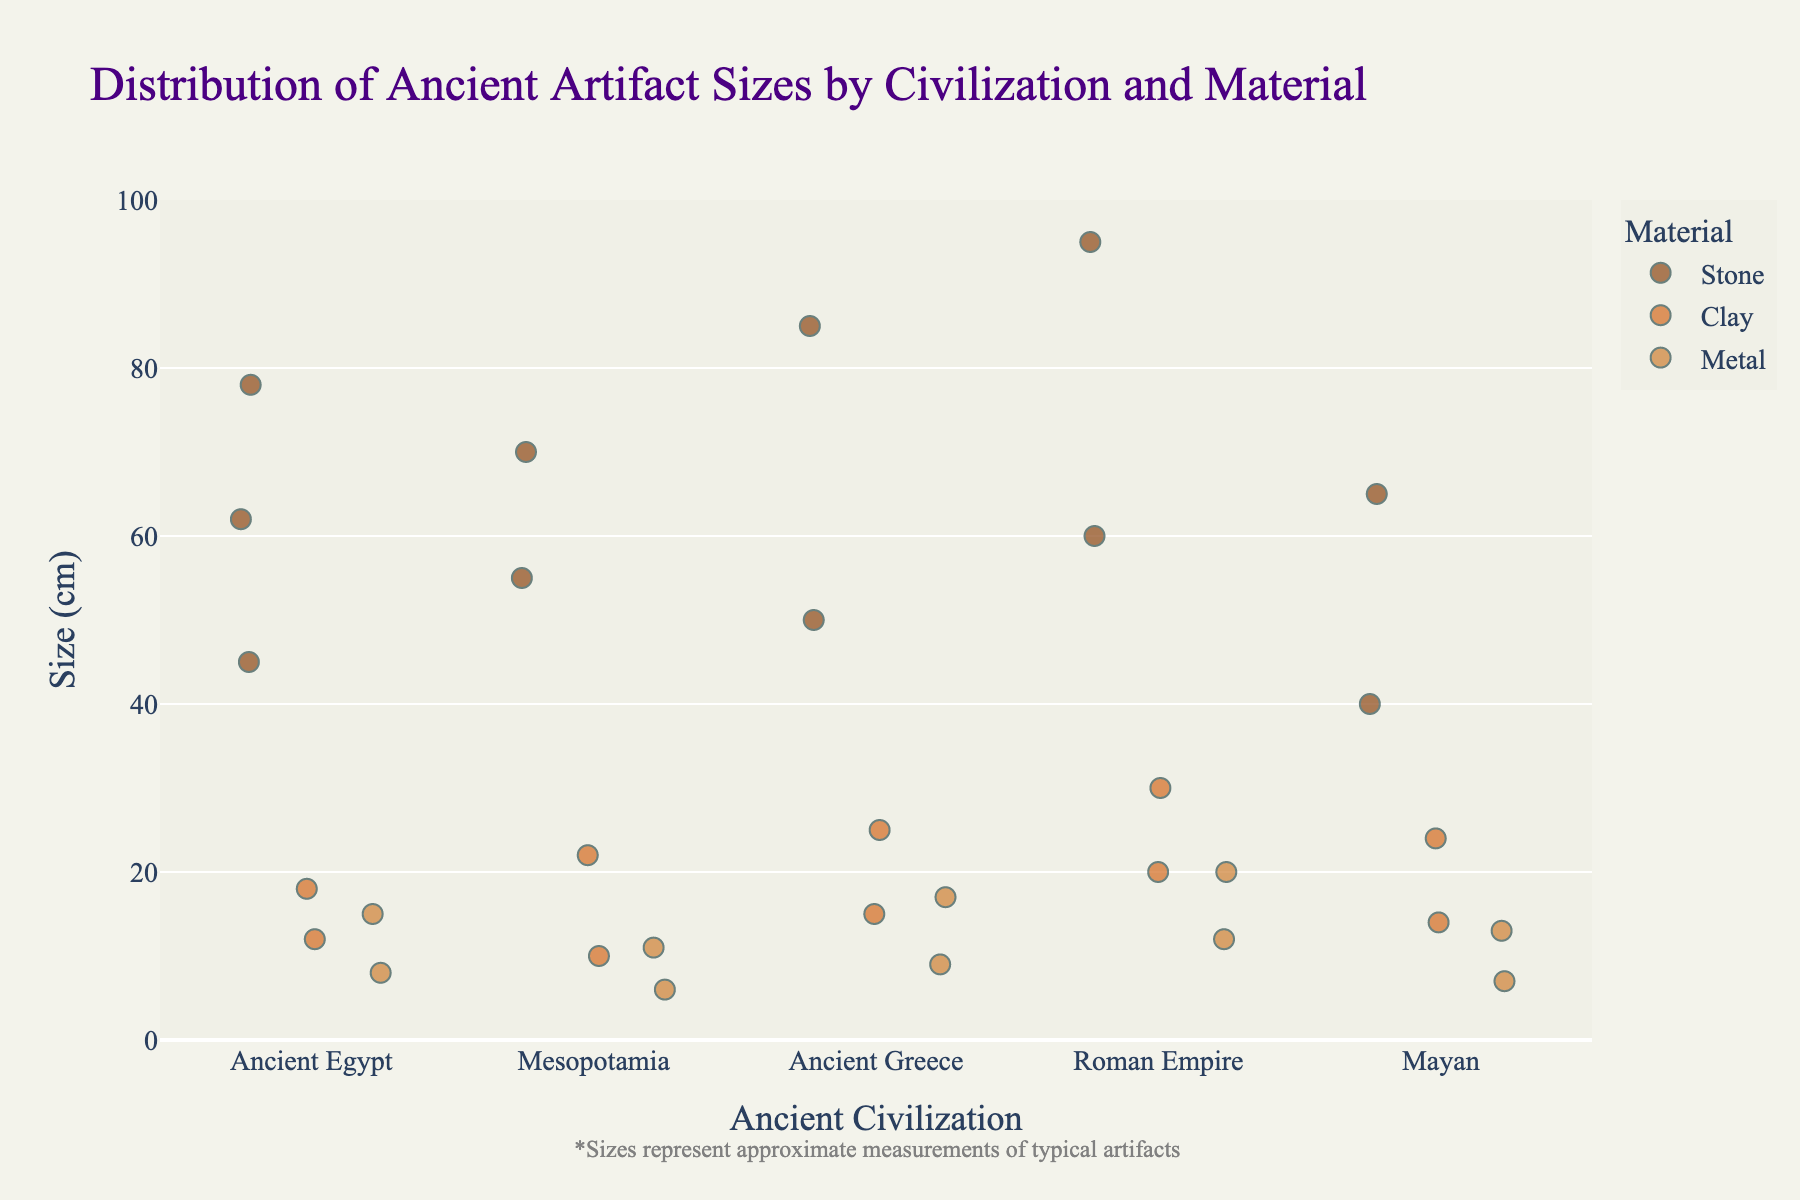What's the title of the plot? The title is usually found at the top of the plot and summarizes what the plot is about.
Answer: Distribution of Ancient Artifact Sizes by Civilization and Material Which civilization has the widest range of stone artifact sizes? By examining the vertical spread of points for "Stone" within each civilization along the x-axis, you can see which one spans the most on the y-axis. The Roman Empire has stone artifacts ranging from 60 cm to 95 cm, the widest range.
Answer: Roman Empire What is the largest artifact size recorded, and which civilization and material does it belong to? Identify the highest data point on the y-axis and match it to its respective civilization and material. The largest artifact is 95 cm and it belongs to the Roman Empire, made of Stone.
Answer: 95 cm, Roman Empire, Stone Which civilization has the most diverse materials for artifacts? Count the number of different materials (colors) for each civilization. Every civilization in the plot has representations of Stone, Clay, and Metal, so they are equally diverse.
Answer: All civilizations What is the average size of metal artifacts from Ancient Greece? Observe the sizes of metal artifacts for Ancient Greece, then sum these values and divide by the number of data points. The sizes are 9 cm and 17 cm. (9 + 17) / 2 = 13 cm.
Answer: 13 cm Which civilization has the smallest clay artifact and what is its size? Locate the position of the lowest clay artifact point on the y-axis and read its size. The Mesopotamia civilization has the smallest clay artifact at 10 cm.
Answer: Mesopotamia, 10 cm How does the average size of artifacts from the Mayan civilization compare to those from Ancient Egypt? Calculate the average artifact size for each civilization by summing all their artifact sizes and dividing by the number of artifacts. Compare these averages to find which is larger or smaller. For the Mayan civilization: (40 + 65 + 14 + 24 + 7 + 13) / 6 = 27.17 cm. For Ancient Egypt: (45 + 62 + 78 + 12 + 18 + 8 + 15) / 7 = 34.14 cm. Mayan artifacts are smaller on average.
Answer: Mayan artifacts are smaller on average Which material generally represents the smallest artifact sizes across all civilizations? Observe each material's spread on the y-axis across all civilizations to determine which material has the majority of smaller sizes. Metal typically represents the smallest artifact sizes.
Answer: Metal What size range do clay artifacts from the Roman Empire fall into? Note the lowest and highest points for clay artifacts within the Roman Empire. They range between 20 cm and 30 cm.
Answer: 20 cm to 30 cm How do the sizes of stone artifacts in Mesopotamia compare to those in Ancient Egypt? Compare the range (minimum and maximum values) of stone artifact sizes between the two civilizations. Stone artifacts in Mesopotamia range between 55 cm and 70 cm, while those in Ancient Egypt range between 45 cm and 78 cm.
Answer: Mesopotamian artifacts are generally smaller with a smaller size range 